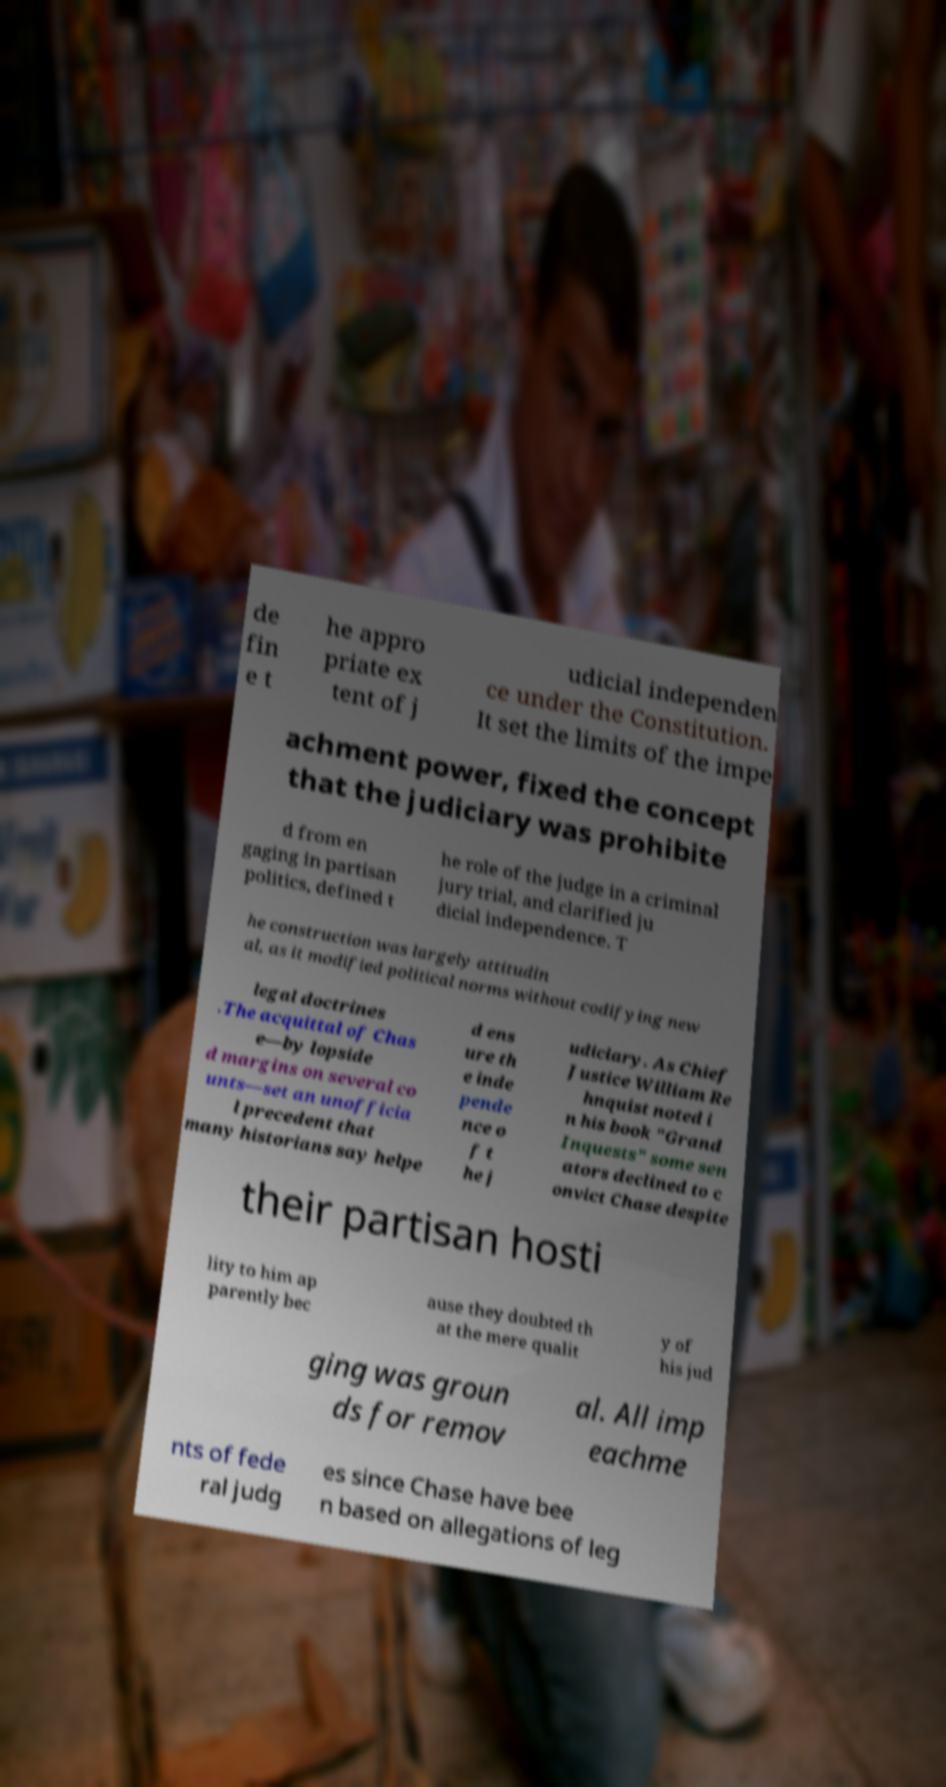Please identify and transcribe the text found in this image. de fin e t he appro priate ex tent of j udicial independen ce under the Constitution. It set the limits of the impe achment power, fixed the concept that the judiciary was prohibite d from en gaging in partisan politics, defined t he role of the judge in a criminal jury trial, and clarified ju dicial independence. T he construction was largely attitudin al, as it modified political norms without codifying new legal doctrines .The acquittal of Chas e—by lopside d margins on several co unts—set an unofficia l precedent that many historians say helpe d ens ure th e inde pende nce o f t he j udiciary. As Chief Justice William Re hnquist noted i n his book "Grand Inquests" some sen ators declined to c onvict Chase despite their partisan hosti lity to him ap parently bec ause they doubted th at the mere qualit y of his jud ging was groun ds for remov al. All imp eachme nts of fede ral judg es since Chase have bee n based on allegations of leg 